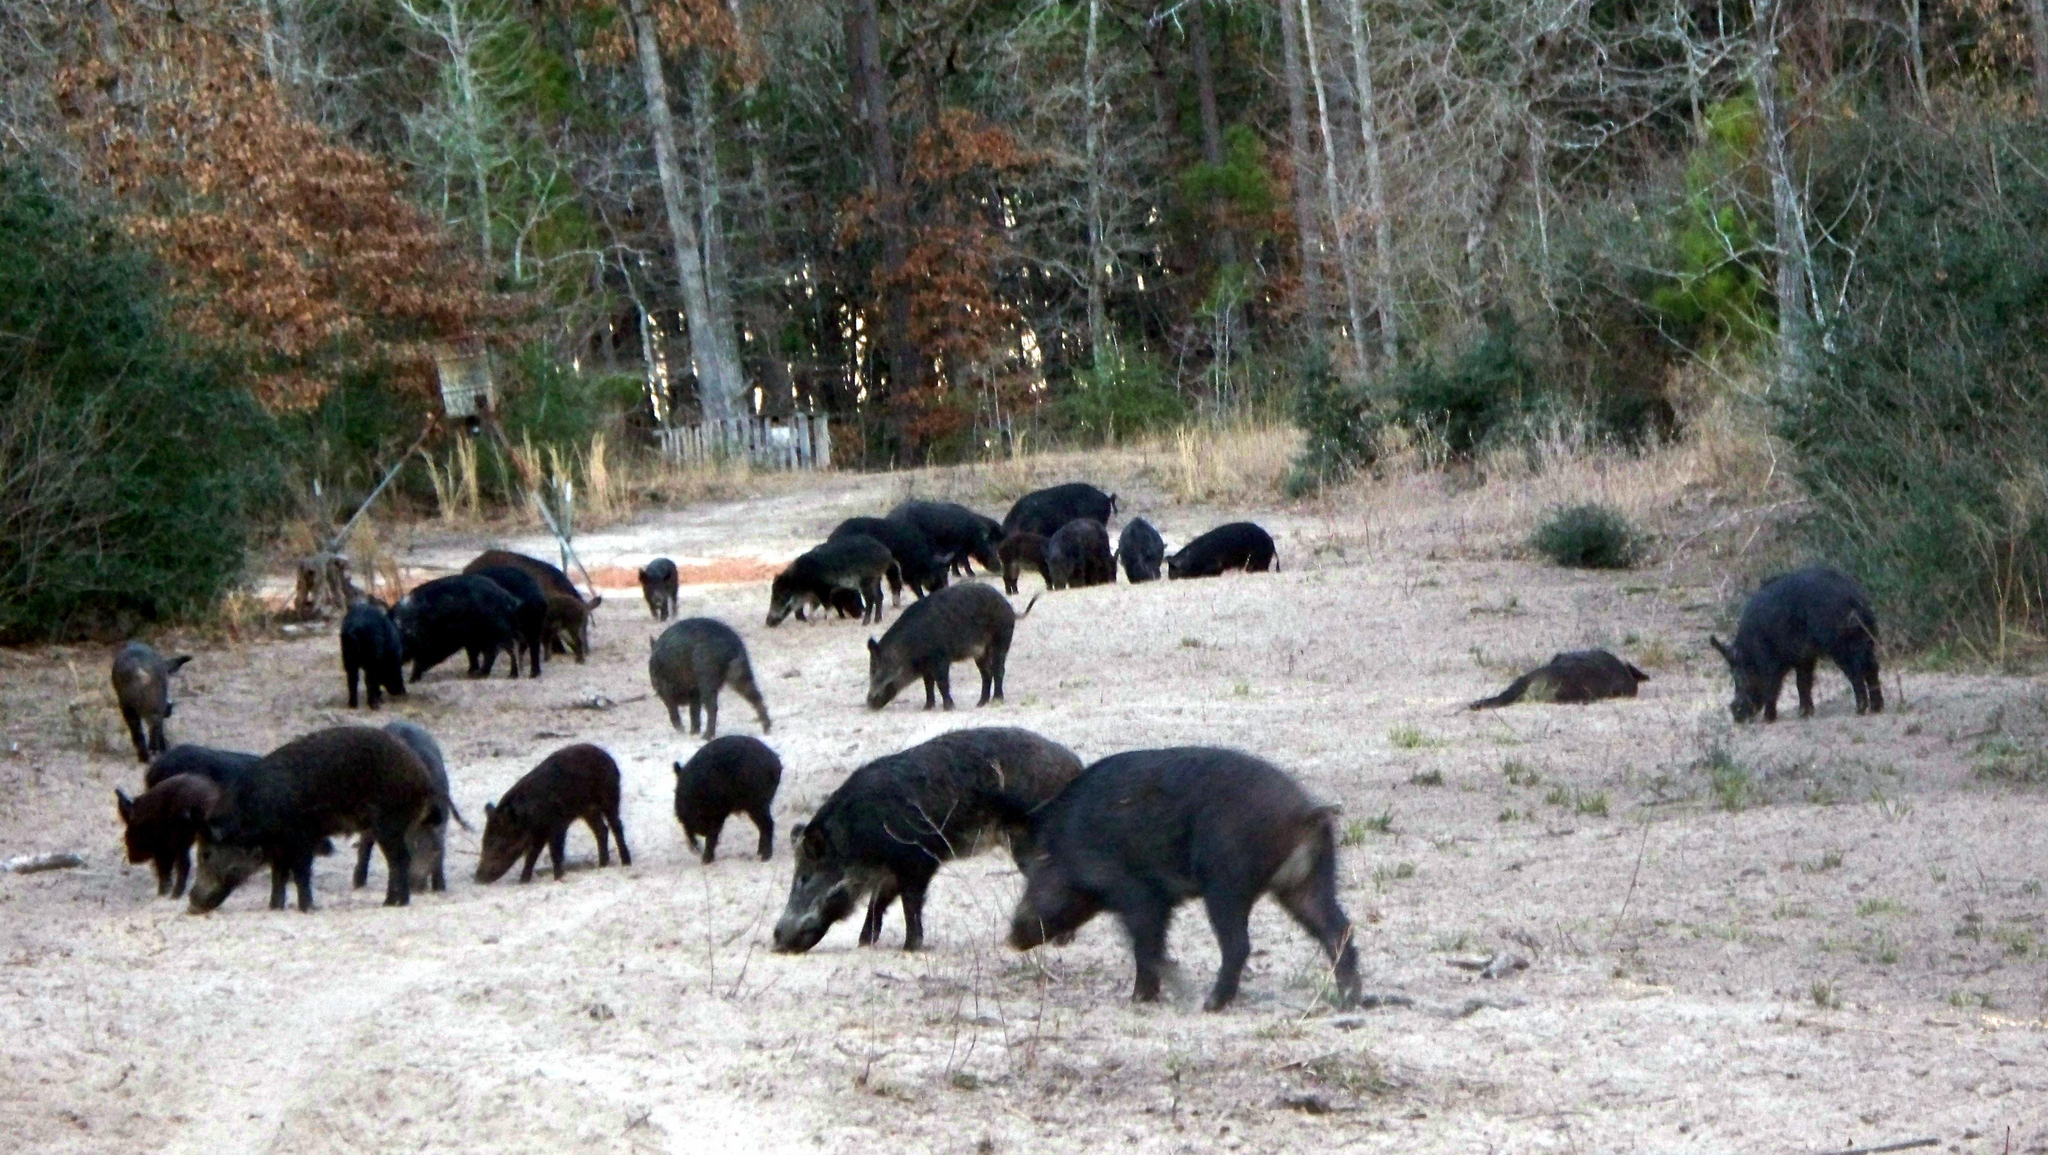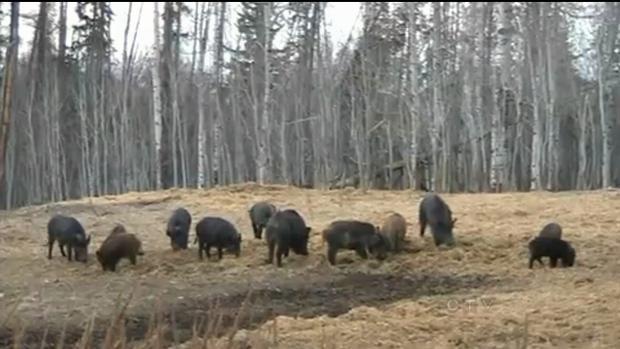The first image is the image on the left, the second image is the image on the right. Evaluate the accuracy of this statement regarding the images: "One or more boars are facing a predator in the right image.". Is it true? Answer yes or no. No. The first image is the image on the left, the second image is the image on the right. Analyze the images presented: Is the assertion "Left image shows at least 8 dark hogs in a cleared area next to foliage." valid? Answer yes or no. Yes. 